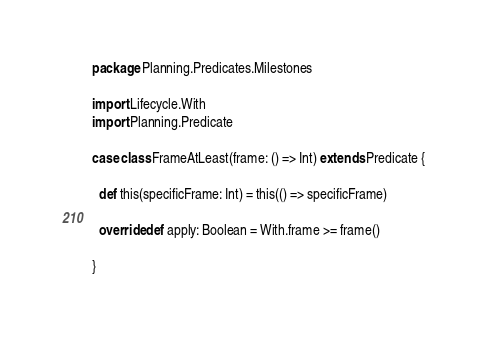Convert code to text. <code><loc_0><loc_0><loc_500><loc_500><_Scala_>package Planning.Predicates.Milestones

import Lifecycle.With
import Planning.Predicate

case class FrameAtLeast(frame: () => Int) extends Predicate {

  def this(specificFrame: Int) = this(() => specificFrame)

  override def apply: Boolean = With.frame >= frame()
  
}
</code> 